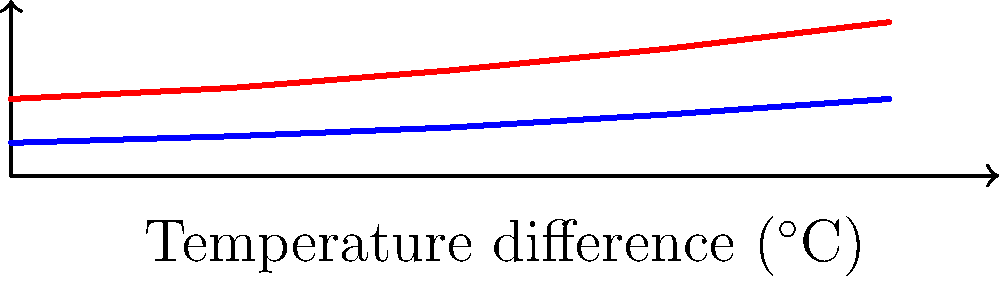Based on the graph showing the thermal conductivity of traditional Japanese walls compared to modern walls, what can be inferred about the insulation properties of traditional construction methods as the temperature difference increases? To answer this question, we need to analyze the graph and understand the relationship between thermal conductivity and insulation properties:

1. The graph shows thermal conductivity (W/m$\cdot$K) on the y-axis and temperature difference ($^\circ$C) on the x-axis.

2. Two lines are plotted: blue for traditional walls and red for modern walls.

3. Thermal conductivity is inversely related to insulation properties. Lower thermal conductivity means better insulation.

4. As the temperature difference increases (moving right on the x-axis):
   a) Both traditional and modern walls show an increase in thermal conductivity.
   b) The slope of the line for traditional walls is less steep than for modern walls.

5. This means that as the temperature difference increases:
   a) The thermal conductivity of traditional walls increases more slowly.
   b) Traditional walls maintain better insulation properties relative to modern walls.

6. At higher temperature differences, the gap between traditional and modern wall thermal conductivity widens, indicating that traditional walls become comparatively more effective at insulation in more extreme temperature conditions.

Therefore, we can infer that traditional Japanese wall construction methods provide better insulation properties, especially as the temperature difference increases.
Answer: Traditional walls maintain better insulation as temperature difference increases. 